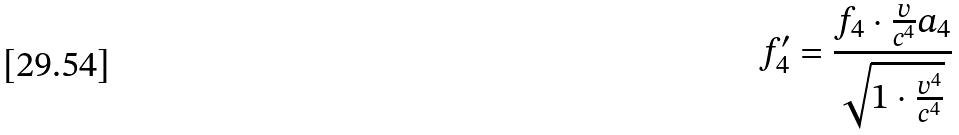<formula> <loc_0><loc_0><loc_500><loc_500>f _ { 4 } ^ { \prime } = \frac { f _ { 4 } \cdot \frac { v } { c ^ { 4 } } a _ { 4 } } { \sqrt { 1 \cdot \frac { v ^ { 4 } } { c ^ { 4 } } } }</formula> 